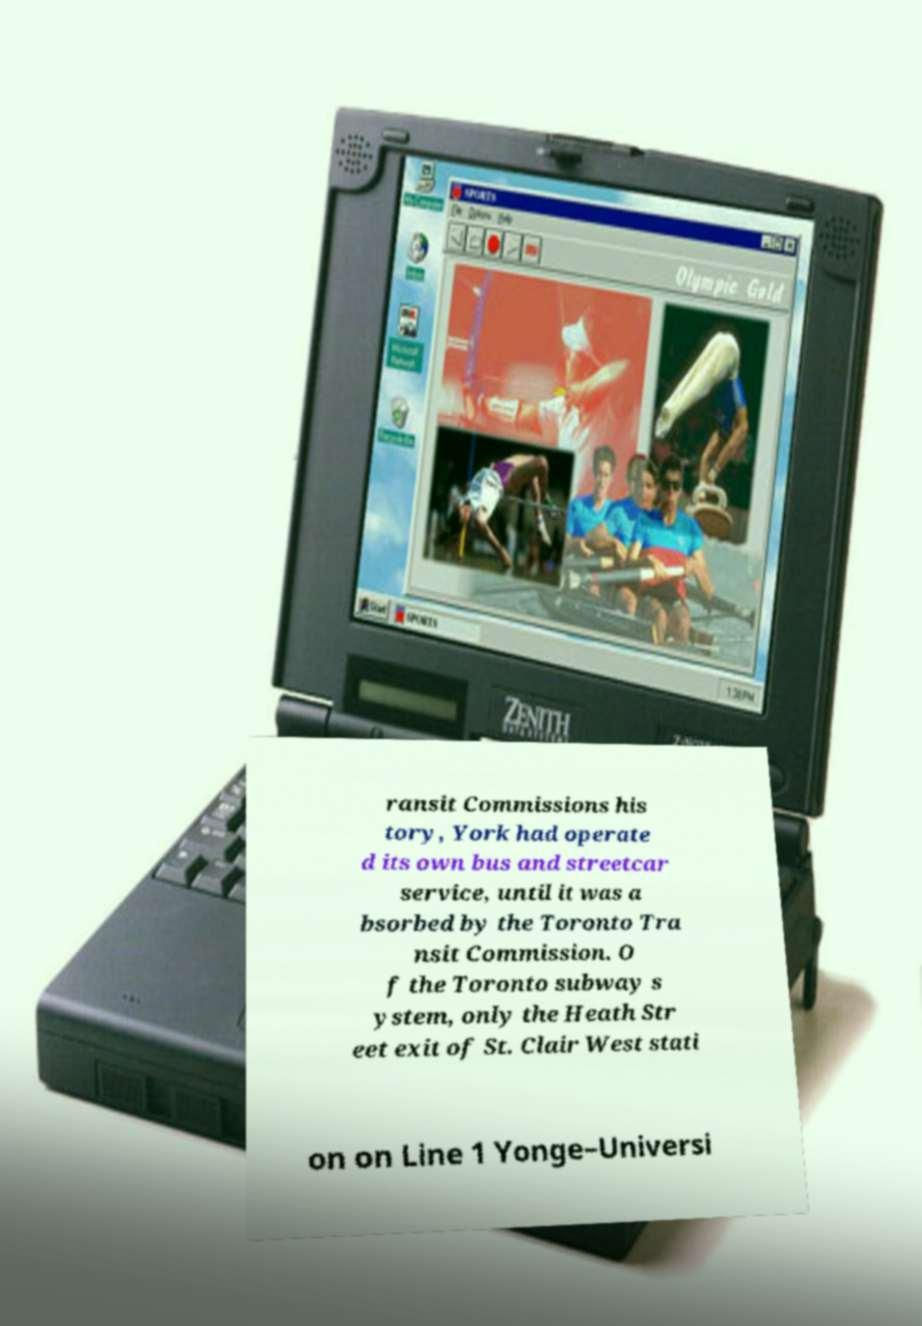Please read and relay the text visible in this image. What does it say? ransit Commissions his tory, York had operate d its own bus and streetcar service, until it was a bsorbed by the Toronto Tra nsit Commission. O f the Toronto subway s ystem, only the Heath Str eet exit of St. Clair West stati on on Line 1 Yonge–Universi 